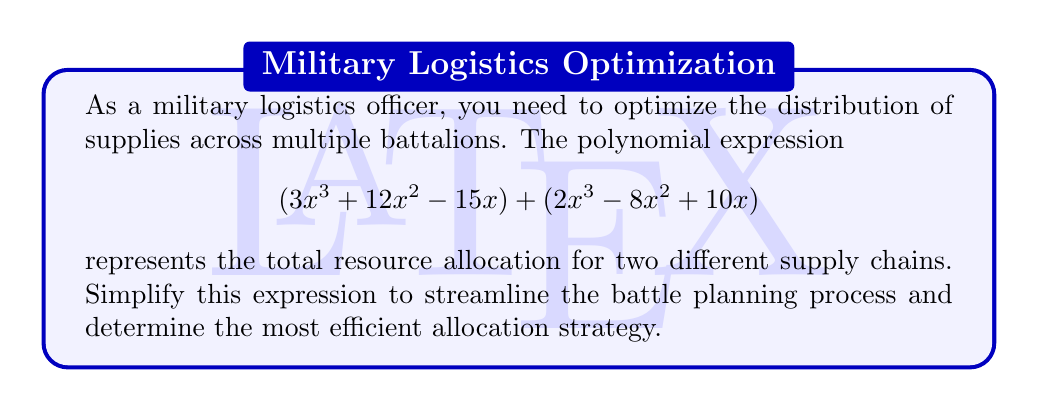Solve this math problem. To simplify this complex polynomial expression, we'll follow these steps:

1) First, let's identify like terms in the expression:
   $$(3x^3 + 12x^2 - 15x) + (2x^3 - 8x^2 + 10x)$$

2) We can rewrite this by grouping like terms:
   $$(3x^3 + 2x^3) + (12x^2 - 8x^2) + (-15x + 10x)$$

3) Now, let's combine like terms:

   For $x^3$ terms: $3x^3 + 2x^3 = 5x^3$
   
   For $x^2$ terms: $12x^2 - 8x^2 = 4x^2$
   
   For $x$ terms: $-15x + 10x = -5x$

4) Putting it all together, we get:

   $$5x^3 + 4x^2 - 5x$$

5) This simplified polynomial cannot be factored further, so this is our final answer.

This simplified expression allows for more efficient resource allocation planning, as it clearly shows the coefficients for each degree of x, representing different levels of supply chain complexity.
Answer: $$5x^3 + 4x^2 - 5x$$ 